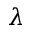<formula> <loc_0><loc_0><loc_500><loc_500>\lambda</formula> 